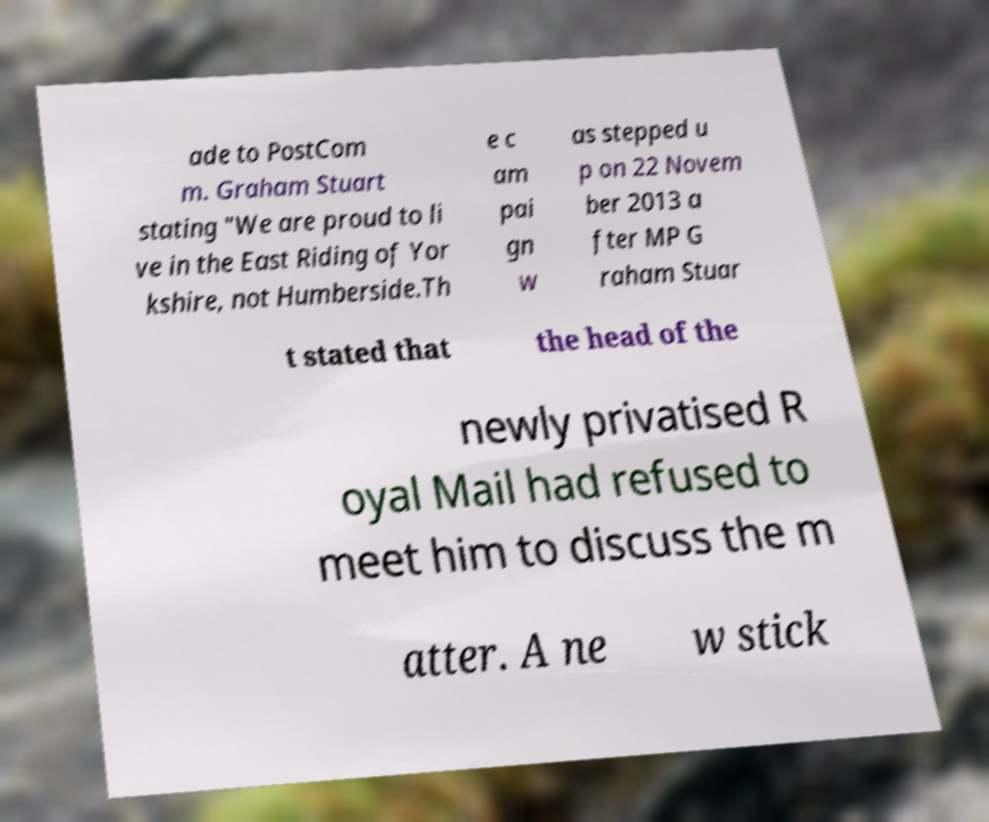Can you read and provide the text displayed in the image?This photo seems to have some interesting text. Can you extract and type it out for me? ade to PostCom m. Graham Stuart stating "We are proud to li ve in the East Riding of Yor kshire, not Humberside.Th e c am pai gn w as stepped u p on 22 Novem ber 2013 a fter MP G raham Stuar t stated that the head of the newly privatised R oyal Mail had refused to meet him to discuss the m atter. A ne w stick 